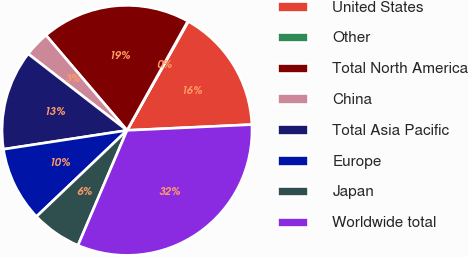Convert chart to OTSL. <chart><loc_0><loc_0><loc_500><loc_500><pie_chart><fcel>United States<fcel>Other<fcel>Total North America<fcel>China<fcel>Total Asia Pacific<fcel>Europe<fcel>Japan<fcel>Worldwide total<nl><fcel>16.11%<fcel>0.07%<fcel>19.32%<fcel>3.28%<fcel>12.9%<fcel>9.69%<fcel>6.48%<fcel>32.15%<nl></chart> 